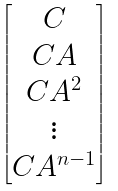Convert formula to latex. <formula><loc_0><loc_0><loc_500><loc_500>\begin{bmatrix} C \\ C A \\ C A ^ { 2 } \\ \vdots \\ C A ^ { n - 1 } \end{bmatrix}</formula> 